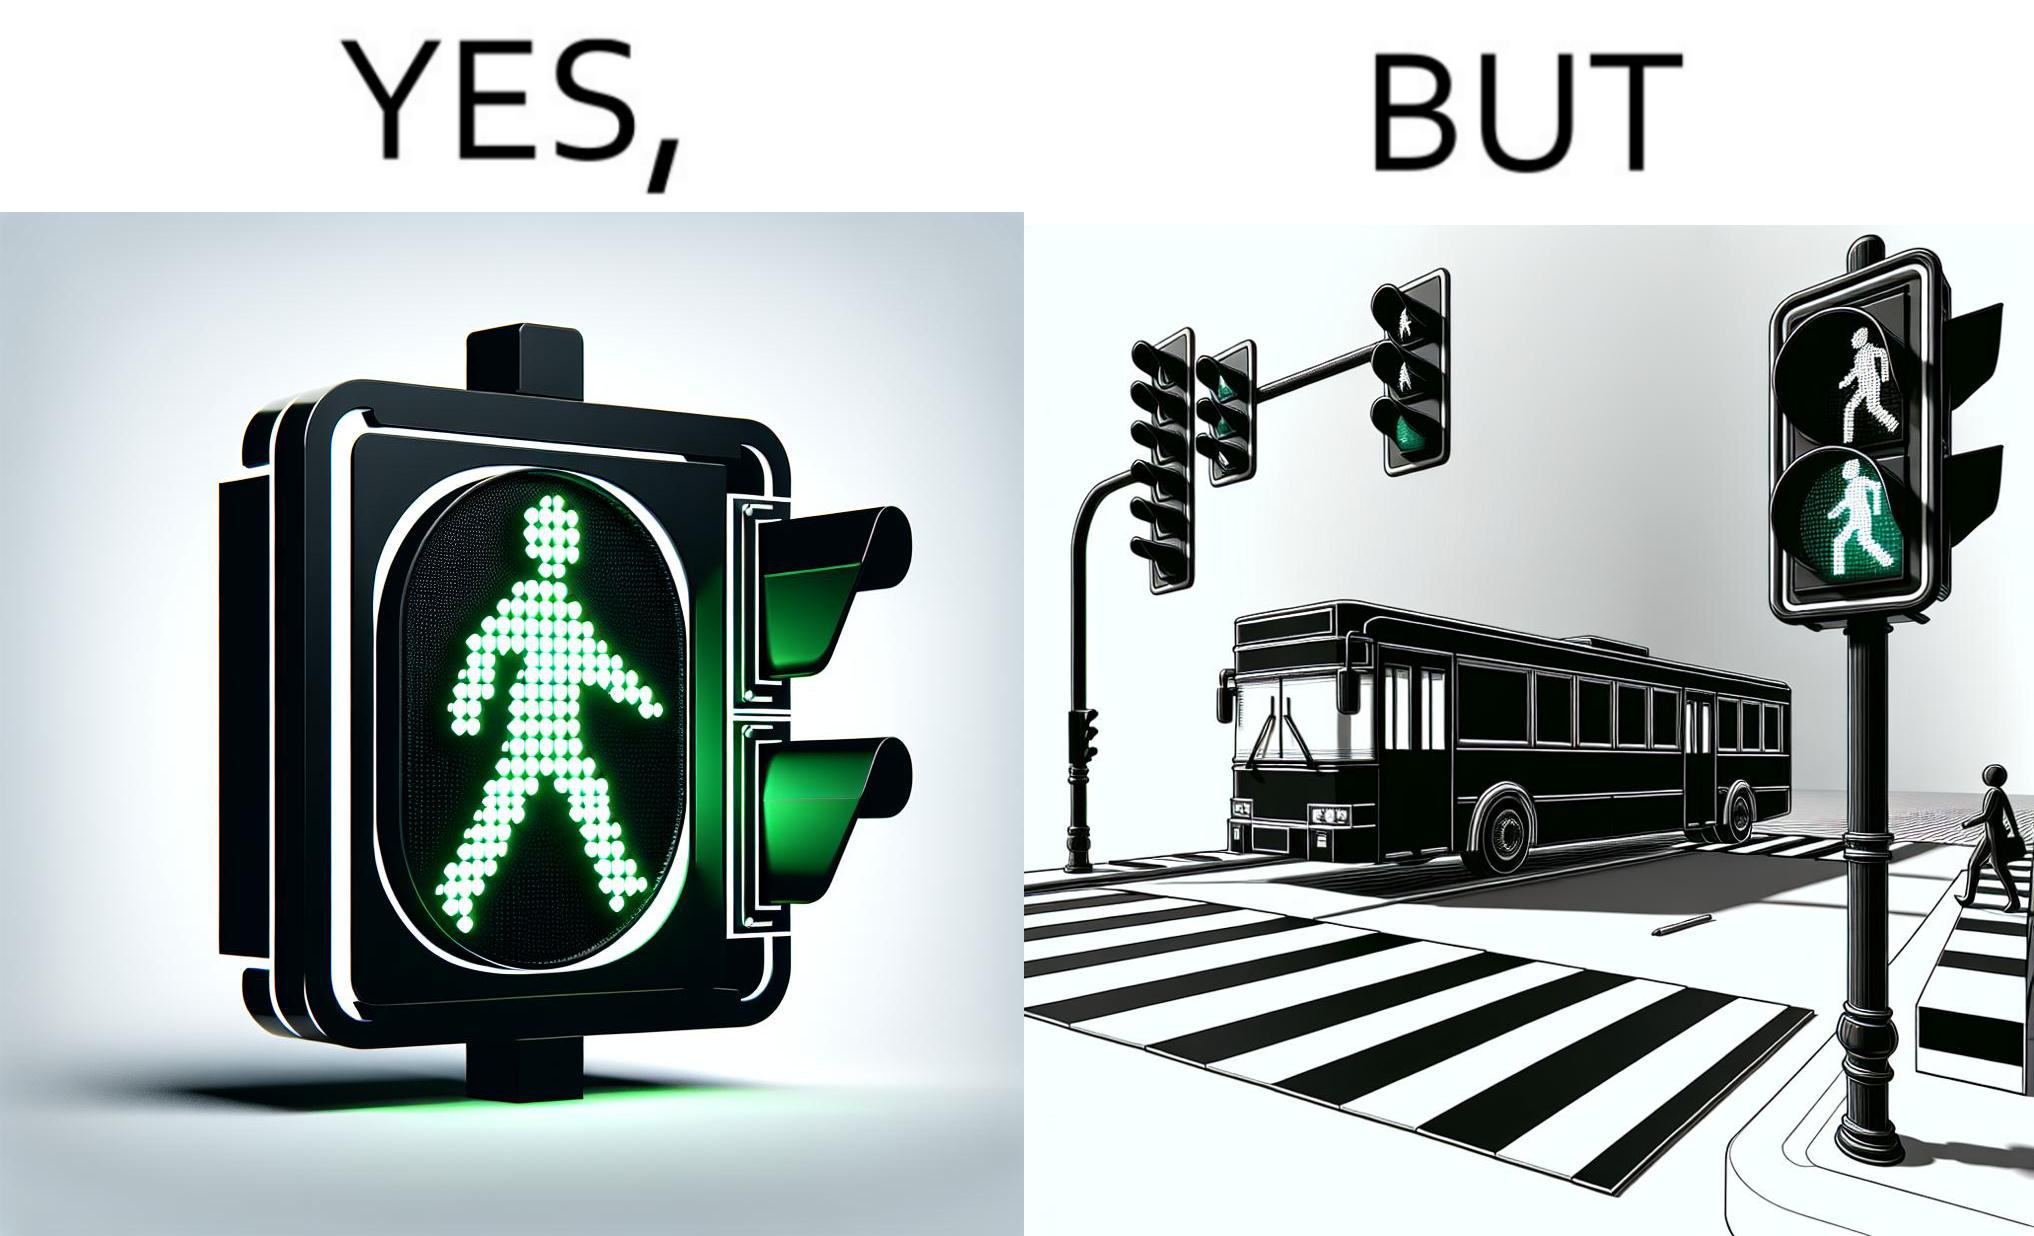Why is this image considered satirical? The image is ironic, because even when the signal is green for the pedestrians but they can't cross the road because of the vehicles standing on the zebra crossing 